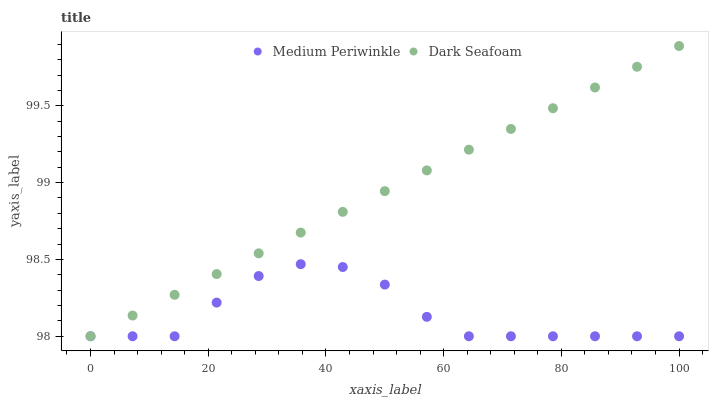Does Medium Periwinkle have the minimum area under the curve?
Answer yes or no. Yes. Does Dark Seafoam have the maximum area under the curve?
Answer yes or no. Yes. Does Medium Periwinkle have the maximum area under the curve?
Answer yes or no. No. Is Dark Seafoam the smoothest?
Answer yes or no. Yes. Is Medium Periwinkle the roughest?
Answer yes or no. Yes. Is Medium Periwinkle the smoothest?
Answer yes or no. No. Does Dark Seafoam have the lowest value?
Answer yes or no. Yes. Does Dark Seafoam have the highest value?
Answer yes or no. Yes. Does Medium Periwinkle have the highest value?
Answer yes or no. No. Does Medium Periwinkle intersect Dark Seafoam?
Answer yes or no. Yes. Is Medium Periwinkle less than Dark Seafoam?
Answer yes or no. No. Is Medium Periwinkle greater than Dark Seafoam?
Answer yes or no. No. 